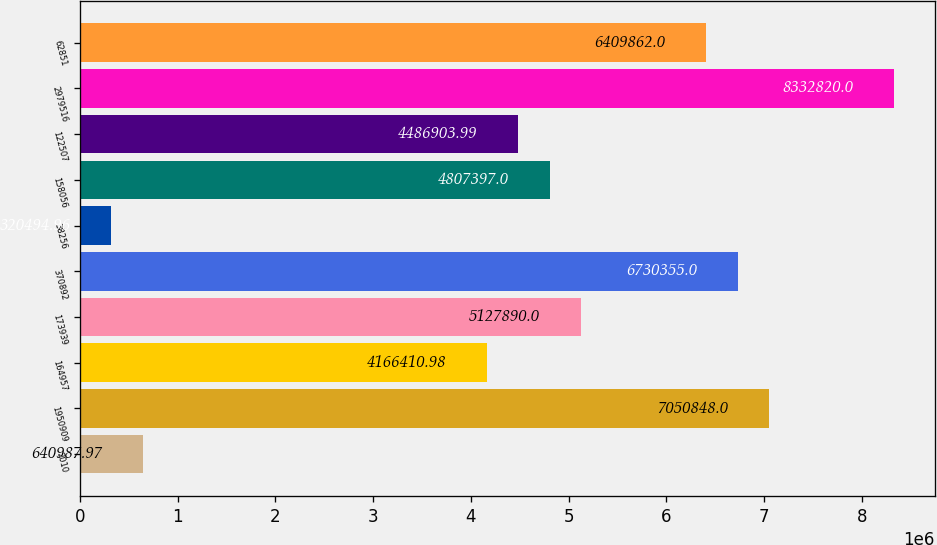Convert chart to OTSL. <chart><loc_0><loc_0><loc_500><loc_500><bar_chart><fcel>2010<fcel>1950909<fcel>164957<fcel>173939<fcel>370892<fcel>38256<fcel>158056<fcel>122507<fcel>2979516<fcel>62851<nl><fcel>640988<fcel>7.05085e+06<fcel>4.16641e+06<fcel>5.12789e+06<fcel>6.73036e+06<fcel>320495<fcel>4.8074e+06<fcel>4.4869e+06<fcel>8.33282e+06<fcel>6.40986e+06<nl></chart> 